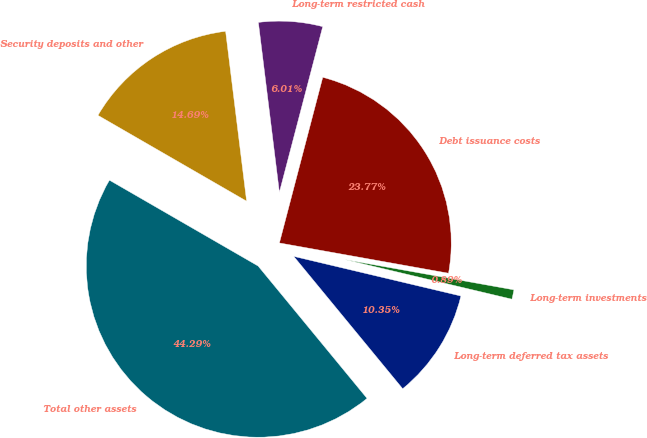<chart> <loc_0><loc_0><loc_500><loc_500><pie_chart><fcel>Long-term deferred tax assets<fcel>Long-term investments<fcel>Debt issuance costs<fcel>Long-term restricted cash<fcel>Security deposits and other<fcel>Total other assets<nl><fcel>10.35%<fcel>0.89%<fcel>23.77%<fcel>6.01%<fcel>14.69%<fcel>44.29%<nl></chart> 